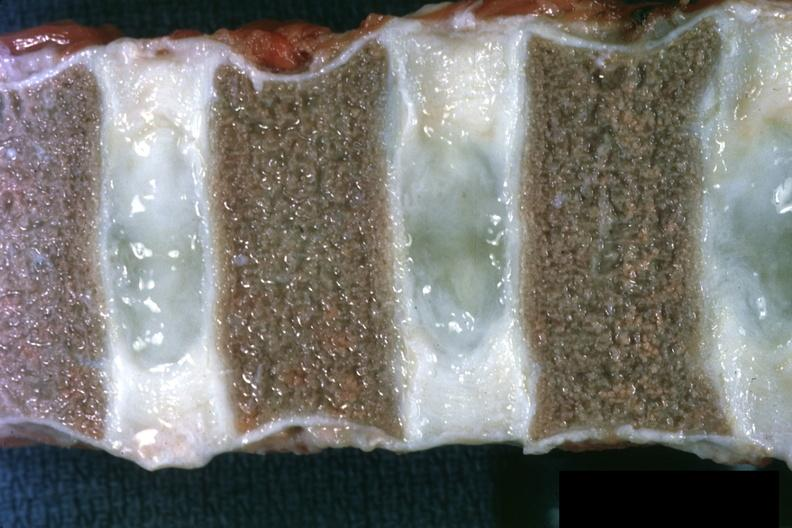does side show close-up view of vertebral marrow not too spectacular discs are well shown and normal also entered into this file as normal discs slide?
Answer the question using a single word or phrase. No 